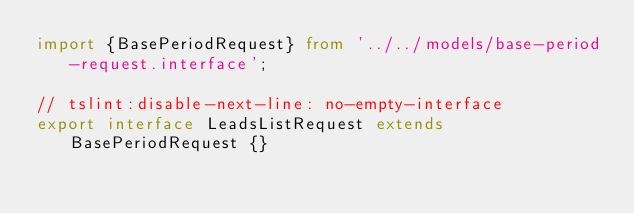Convert code to text. <code><loc_0><loc_0><loc_500><loc_500><_TypeScript_>import {BasePeriodRequest} from '../../models/base-period-request.interface';

// tslint:disable-next-line: no-empty-interface
export interface LeadsListRequest extends BasePeriodRequest {}
</code> 